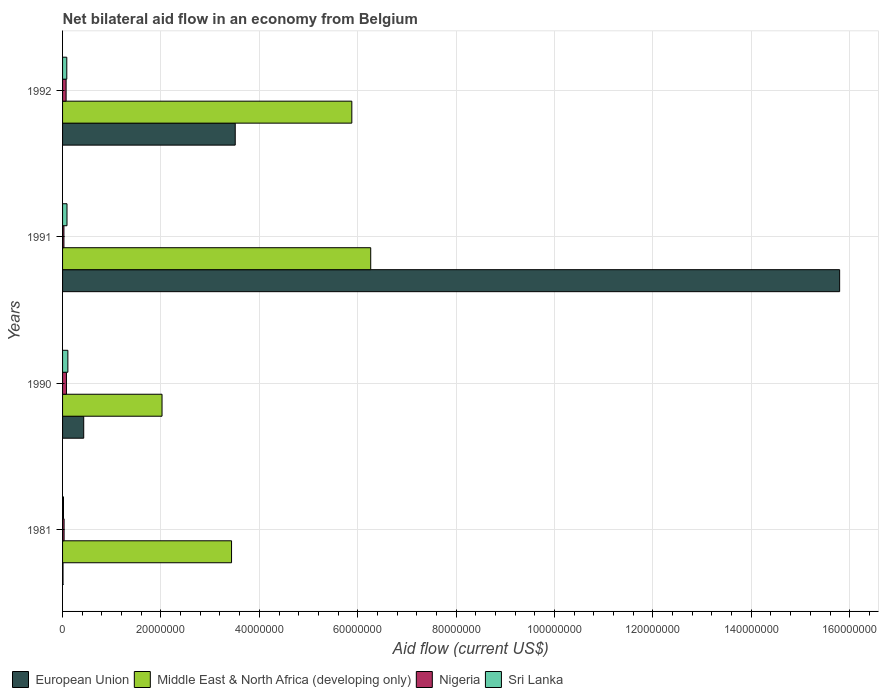How many different coloured bars are there?
Offer a terse response. 4. How many groups of bars are there?
Your response must be concise. 4. Are the number of bars per tick equal to the number of legend labels?
Your response must be concise. Yes. Are the number of bars on each tick of the Y-axis equal?
Offer a very short reply. Yes. What is the label of the 2nd group of bars from the top?
Offer a very short reply. 1991. In how many cases, is the number of bars for a given year not equal to the number of legend labels?
Give a very brief answer. 0. What is the net bilateral aid flow in Middle East & North Africa (developing only) in 1990?
Offer a terse response. 2.02e+07. Across all years, what is the maximum net bilateral aid flow in Sri Lanka?
Provide a short and direct response. 1.08e+06. In which year was the net bilateral aid flow in Middle East & North Africa (developing only) maximum?
Offer a terse response. 1991. What is the total net bilateral aid flow in Middle East & North Africa (developing only) in the graph?
Your answer should be compact. 1.76e+08. What is the difference between the net bilateral aid flow in European Union in 1991 and that in 1992?
Your answer should be compact. 1.23e+08. What is the difference between the net bilateral aid flow in European Union in 1981 and the net bilateral aid flow in Sri Lanka in 1990?
Make the answer very short. -9.90e+05. What is the average net bilateral aid flow in Middle East & North Africa (developing only) per year?
Offer a very short reply. 4.40e+07. In how many years, is the net bilateral aid flow in Sri Lanka greater than 84000000 US$?
Ensure brevity in your answer.  0. What is the ratio of the net bilateral aid flow in European Union in 1981 to that in 1992?
Your response must be concise. 0. Is the net bilateral aid flow in Middle East & North Africa (developing only) in 1981 less than that in 1991?
Your answer should be compact. Yes. What is the difference between the highest and the second highest net bilateral aid flow in Middle East & North Africa (developing only)?
Your answer should be very brief. 3.84e+06. What is the difference between the highest and the lowest net bilateral aid flow in Middle East & North Africa (developing only)?
Your response must be concise. 4.24e+07. Is it the case that in every year, the sum of the net bilateral aid flow in Middle East & North Africa (developing only) and net bilateral aid flow in European Union is greater than the sum of net bilateral aid flow in Sri Lanka and net bilateral aid flow in Nigeria?
Provide a short and direct response. Yes. What does the 2nd bar from the top in 1981 represents?
Your response must be concise. Nigeria. What does the 4th bar from the bottom in 1981 represents?
Offer a terse response. Sri Lanka. Is it the case that in every year, the sum of the net bilateral aid flow in Nigeria and net bilateral aid flow in Middle East & North Africa (developing only) is greater than the net bilateral aid flow in European Union?
Give a very brief answer. No. How many years are there in the graph?
Offer a very short reply. 4. What is the difference between two consecutive major ticks on the X-axis?
Make the answer very short. 2.00e+07. How many legend labels are there?
Offer a terse response. 4. How are the legend labels stacked?
Your answer should be very brief. Horizontal. What is the title of the graph?
Your answer should be very brief. Net bilateral aid flow in an economy from Belgium. Does "Slovenia" appear as one of the legend labels in the graph?
Offer a terse response. No. What is the label or title of the Y-axis?
Make the answer very short. Years. What is the Aid flow (current US$) of European Union in 1981?
Provide a short and direct response. 9.00e+04. What is the Aid flow (current US$) of Middle East & North Africa (developing only) in 1981?
Your response must be concise. 3.44e+07. What is the Aid flow (current US$) of Nigeria in 1981?
Make the answer very short. 3.10e+05. What is the Aid flow (current US$) in Sri Lanka in 1981?
Provide a succinct answer. 1.90e+05. What is the Aid flow (current US$) of European Union in 1990?
Give a very brief answer. 4.30e+06. What is the Aid flow (current US$) of Middle East & North Africa (developing only) in 1990?
Your response must be concise. 2.02e+07. What is the Aid flow (current US$) of Nigeria in 1990?
Give a very brief answer. 7.90e+05. What is the Aid flow (current US$) in Sri Lanka in 1990?
Offer a very short reply. 1.08e+06. What is the Aid flow (current US$) in European Union in 1991?
Offer a terse response. 1.58e+08. What is the Aid flow (current US$) of Middle East & North Africa (developing only) in 1991?
Keep it short and to the point. 6.26e+07. What is the Aid flow (current US$) in European Union in 1992?
Your answer should be very brief. 3.51e+07. What is the Aid flow (current US$) of Middle East & North Africa (developing only) in 1992?
Provide a succinct answer. 5.88e+07. What is the Aid flow (current US$) in Nigeria in 1992?
Your answer should be compact. 7.20e+05. What is the Aid flow (current US$) of Sri Lanka in 1992?
Make the answer very short. 8.60e+05. Across all years, what is the maximum Aid flow (current US$) of European Union?
Offer a terse response. 1.58e+08. Across all years, what is the maximum Aid flow (current US$) in Middle East & North Africa (developing only)?
Your answer should be compact. 6.26e+07. Across all years, what is the maximum Aid flow (current US$) in Nigeria?
Give a very brief answer. 7.90e+05. Across all years, what is the maximum Aid flow (current US$) of Sri Lanka?
Provide a short and direct response. 1.08e+06. Across all years, what is the minimum Aid flow (current US$) in Middle East & North Africa (developing only)?
Give a very brief answer. 2.02e+07. Across all years, what is the minimum Aid flow (current US$) of Nigeria?
Provide a succinct answer. 2.80e+05. Across all years, what is the minimum Aid flow (current US$) in Sri Lanka?
Offer a terse response. 1.90e+05. What is the total Aid flow (current US$) in European Union in the graph?
Your response must be concise. 1.97e+08. What is the total Aid flow (current US$) of Middle East & North Africa (developing only) in the graph?
Offer a very short reply. 1.76e+08. What is the total Aid flow (current US$) of Nigeria in the graph?
Offer a terse response. 2.10e+06. What is the total Aid flow (current US$) in Sri Lanka in the graph?
Offer a terse response. 3.03e+06. What is the difference between the Aid flow (current US$) of European Union in 1981 and that in 1990?
Offer a very short reply. -4.21e+06. What is the difference between the Aid flow (current US$) of Middle East & North Africa (developing only) in 1981 and that in 1990?
Provide a succinct answer. 1.41e+07. What is the difference between the Aid flow (current US$) in Nigeria in 1981 and that in 1990?
Provide a succinct answer. -4.80e+05. What is the difference between the Aid flow (current US$) in Sri Lanka in 1981 and that in 1990?
Provide a short and direct response. -8.90e+05. What is the difference between the Aid flow (current US$) in European Union in 1981 and that in 1991?
Your response must be concise. -1.58e+08. What is the difference between the Aid flow (current US$) in Middle East & North Africa (developing only) in 1981 and that in 1991?
Give a very brief answer. -2.83e+07. What is the difference between the Aid flow (current US$) of Nigeria in 1981 and that in 1991?
Offer a terse response. 3.00e+04. What is the difference between the Aid flow (current US$) in Sri Lanka in 1981 and that in 1991?
Keep it short and to the point. -7.10e+05. What is the difference between the Aid flow (current US$) in European Union in 1981 and that in 1992?
Make the answer very short. -3.50e+07. What is the difference between the Aid flow (current US$) in Middle East & North Africa (developing only) in 1981 and that in 1992?
Your answer should be compact. -2.44e+07. What is the difference between the Aid flow (current US$) in Nigeria in 1981 and that in 1992?
Offer a very short reply. -4.10e+05. What is the difference between the Aid flow (current US$) of Sri Lanka in 1981 and that in 1992?
Keep it short and to the point. -6.70e+05. What is the difference between the Aid flow (current US$) of European Union in 1990 and that in 1991?
Offer a terse response. -1.54e+08. What is the difference between the Aid flow (current US$) in Middle East & North Africa (developing only) in 1990 and that in 1991?
Make the answer very short. -4.24e+07. What is the difference between the Aid flow (current US$) of Nigeria in 1990 and that in 1991?
Give a very brief answer. 5.10e+05. What is the difference between the Aid flow (current US$) in Sri Lanka in 1990 and that in 1991?
Your answer should be compact. 1.80e+05. What is the difference between the Aid flow (current US$) in European Union in 1990 and that in 1992?
Your answer should be compact. -3.08e+07. What is the difference between the Aid flow (current US$) of Middle East & North Africa (developing only) in 1990 and that in 1992?
Your answer should be compact. -3.86e+07. What is the difference between the Aid flow (current US$) in Nigeria in 1990 and that in 1992?
Provide a succinct answer. 7.00e+04. What is the difference between the Aid flow (current US$) in Sri Lanka in 1990 and that in 1992?
Give a very brief answer. 2.20e+05. What is the difference between the Aid flow (current US$) of European Union in 1991 and that in 1992?
Give a very brief answer. 1.23e+08. What is the difference between the Aid flow (current US$) of Middle East & North Africa (developing only) in 1991 and that in 1992?
Keep it short and to the point. 3.84e+06. What is the difference between the Aid flow (current US$) in Nigeria in 1991 and that in 1992?
Make the answer very short. -4.40e+05. What is the difference between the Aid flow (current US$) of European Union in 1981 and the Aid flow (current US$) of Middle East & North Africa (developing only) in 1990?
Ensure brevity in your answer.  -2.01e+07. What is the difference between the Aid flow (current US$) in European Union in 1981 and the Aid flow (current US$) in Nigeria in 1990?
Keep it short and to the point. -7.00e+05. What is the difference between the Aid flow (current US$) in European Union in 1981 and the Aid flow (current US$) in Sri Lanka in 1990?
Make the answer very short. -9.90e+05. What is the difference between the Aid flow (current US$) in Middle East & North Africa (developing only) in 1981 and the Aid flow (current US$) in Nigeria in 1990?
Your answer should be compact. 3.36e+07. What is the difference between the Aid flow (current US$) of Middle East & North Africa (developing only) in 1981 and the Aid flow (current US$) of Sri Lanka in 1990?
Ensure brevity in your answer.  3.33e+07. What is the difference between the Aid flow (current US$) of Nigeria in 1981 and the Aid flow (current US$) of Sri Lanka in 1990?
Your answer should be very brief. -7.70e+05. What is the difference between the Aid flow (current US$) of European Union in 1981 and the Aid flow (current US$) of Middle East & North Africa (developing only) in 1991?
Keep it short and to the point. -6.26e+07. What is the difference between the Aid flow (current US$) in European Union in 1981 and the Aid flow (current US$) in Sri Lanka in 1991?
Offer a terse response. -8.10e+05. What is the difference between the Aid flow (current US$) in Middle East & North Africa (developing only) in 1981 and the Aid flow (current US$) in Nigeria in 1991?
Give a very brief answer. 3.41e+07. What is the difference between the Aid flow (current US$) of Middle East & North Africa (developing only) in 1981 and the Aid flow (current US$) of Sri Lanka in 1991?
Make the answer very short. 3.34e+07. What is the difference between the Aid flow (current US$) of Nigeria in 1981 and the Aid flow (current US$) of Sri Lanka in 1991?
Your answer should be compact. -5.90e+05. What is the difference between the Aid flow (current US$) in European Union in 1981 and the Aid flow (current US$) in Middle East & North Africa (developing only) in 1992?
Keep it short and to the point. -5.87e+07. What is the difference between the Aid flow (current US$) of European Union in 1981 and the Aid flow (current US$) of Nigeria in 1992?
Your answer should be very brief. -6.30e+05. What is the difference between the Aid flow (current US$) in European Union in 1981 and the Aid flow (current US$) in Sri Lanka in 1992?
Your answer should be compact. -7.70e+05. What is the difference between the Aid flow (current US$) of Middle East & North Africa (developing only) in 1981 and the Aid flow (current US$) of Nigeria in 1992?
Offer a terse response. 3.36e+07. What is the difference between the Aid flow (current US$) in Middle East & North Africa (developing only) in 1981 and the Aid flow (current US$) in Sri Lanka in 1992?
Your response must be concise. 3.35e+07. What is the difference between the Aid flow (current US$) of Nigeria in 1981 and the Aid flow (current US$) of Sri Lanka in 1992?
Offer a terse response. -5.50e+05. What is the difference between the Aid flow (current US$) of European Union in 1990 and the Aid flow (current US$) of Middle East & North Africa (developing only) in 1991?
Give a very brief answer. -5.83e+07. What is the difference between the Aid flow (current US$) of European Union in 1990 and the Aid flow (current US$) of Nigeria in 1991?
Offer a terse response. 4.02e+06. What is the difference between the Aid flow (current US$) of European Union in 1990 and the Aid flow (current US$) of Sri Lanka in 1991?
Make the answer very short. 3.40e+06. What is the difference between the Aid flow (current US$) in Middle East & North Africa (developing only) in 1990 and the Aid flow (current US$) in Nigeria in 1991?
Offer a very short reply. 1.99e+07. What is the difference between the Aid flow (current US$) of Middle East & North Africa (developing only) in 1990 and the Aid flow (current US$) of Sri Lanka in 1991?
Provide a short and direct response. 1.93e+07. What is the difference between the Aid flow (current US$) in European Union in 1990 and the Aid flow (current US$) in Middle East & North Africa (developing only) in 1992?
Your answer should be very brief. -5.45e+07. What is the difference between the Aid flow (current US$) of European Union in 1990 and the Aid flow (current US$) of Nigeria in 1992?
Provide a short and direct response. 3.58e+06. What is the difference between the Aid flow (current US$) in European Union in 1990 and the Aid flow (current US$) in Sri Lanka in 1992?
Offer a very short reply. 3.44e+06. What is the difference between the Aid flow (current US$) of Middle East & North Africa (developing only) in 1990 and the Aid flow (current US$) of Nigeria in 1992?
Ensure brevity in your answer.  1.95e+07. What is the difference between the Aid flow (current US$) of Middle East & North Africa (developing only) in 1990 and the Aid flow (current US$) of Sri Lanka in 1992?
Offer a terse response. 1.94e+07. What is the difference between the Aid flow (current US$) in Nigeria in 1990 and the Aid flow (current US$) in Sri Lanka in 1992?
Your answer should be compact. -7.00e+04. What is the difference between the Aid flow (current US$) in European Union in 1991 and the Aid flow (current US$) in Middle East & North Africa (developing only) in 1992?
Provide a succinct answer. 9.92e+07. What is the difference between the Aid flow (current US$) in European Union in 1991 and the Aid flow (current US$) in Nigeria in 1992?
Your response must be concise. 1.57e+08. What is the difference between the Aid flow (current US$) of European Union in 1991 and the Aid flow (current US$) of Sri Lanka in 1992?
Provide a short and direct response. 1.57e+08. What is the difference between the Aid flow (current US$) in Middle East & North Africa (developing only) in 1991 and the Aid flow (current US$) in Nigeria in 1992?
Provide a short and direct response. 6.19e+07. What is the difference between the Aid flow (current US$) of Middle East & North Africa (developing only) in 1991 and the Aid flow (current US$) of Sri Lanka in 1992?
Offer a terse response. 6.18e+07. What is the difference between the Aid flow (current US$) in Nigeria in 1991 and the Aid flow (current US$) in Sri Lanka in 1992?
Keep it short and to the point. -5.80e+05. What is the average Aid flow (current US$) of European Union per year?
Your response must be concise. 4.94e+07. What is the average Aid flow (current US$) of Middle East & North Africa (developing only) per year?
Offer a very short reply. 4.40e+07. What is the average Aid flow (current US$) of Nigeria per year?
Your answer should be compact. 5.25e+05. What is the average Aid flow (current US$) in Sri Lanka per year?
Your response must be concise. 7.58e+05. In the year 1981, what is the difference between the Aid flow (current US$) in European Union and Aid flow (current US$) in Middle East & North Africa (developing only)?
Provide a succinct answer. -3.43e+07. In the year 1981, what is the difference between the Aid flow (current US$) in European Union and Aid flow (current US$) in Sri Lanka?
Offer a terse response. -1.00e+05. In the year 1981, what is the difference between the Aid flow (current US$) in Middle East & North Africa (developing only) and Aid flow (current US$) in Nigeria?
Offer a very short reply. 3.40e+07. In the year 1981, what is the difference between the Aid flow (current US$) of Middle East & North Africa (developing only) and Aid flow (current US$) of Sri Lanka?
Keep it short and to the point. 3.42e+07. In the year 1990, what is the difference between the Aid flow (current US$) in European Union and Aid flow (current US$) in Middle East & North Africa (developing only)?
Keep it short and to the point. -1.59e+07. In the year 1990, what is the difference between the Aid flow (current US$) in European Union and Aid flow (current US$) in Nigeria?
Your answer should be compact. 3.51e+06. In the year 1990, what is the difference between the Aid flow (current US$) of European Union and Aid flow (current US$) of Sri Lanka?
Give a very brief answer. 3.22e+06. In the year 1990, what is the difference between the Aid flow (current US$) in Middle East & North Africa (developing only) and Aid flow (current US$) in Nigeria?
Your response must be concise. 1.94e+07. In the year 1990, what is the difference between the Aid flow (current US$) in Middle East & North Africa (developing only) and Aid flow (current US$) in Sri Lanka?
Your answer should be very brief. 1.91e+07. In the year 1990, what is the difference between the Aid flow (current US$) of Nigeria and Aid flow (current US$) of Sri Lanka?
Your answer should be very brief. -2.90e+05. In the year 1991, what is the difference between the Aid flow (current US$) in European Union and Aid flow (current US$) in Middle East & North Africa (developing only)?
Provide a succinct answer. 9.53e+07. In the year 1991, what is the difference between the Aid flow (current US$) in European Union and Aid flow (current US$) in Nigeria?
Offer a terse response. 1.58e+08. In the year 1991, what is the difference between the Aid flow (current US$) of European Union and Aid flow (current US$) of Sri Lanka?
Your answer should be compact. 1.57e+08. In the year 1991, what is the difference between the Aid flow (current US$) in Middle East & North Africa (developing only) and Aid flow (current US$) in Nigeria?
Your response must be concise. 6.24e+07. In the year 1991, what is the difference between the Aid flow (current US$) in Middle East & North Africa (developing only) and Aid flow (current US$) in Sri Lanka?
Offer a terse response. 6.17e+07. In the year 1991, what is the difference between the Aid flow (current US$) of Nigeria and Aid flow (current US$) of Sri Lanka?
Your answer should be very brief. -6.20e+05. In the year 1992, what is the difference between the Aid flow (current US$) in European Union and Aid flow (current US$) in Middle East & North Africa (developing only)?
Keep it short and to the point. -2.37e+07. In the year 1992, what is the difference between the Aid flow (current US$) in European Union and Aid flow (current US$) in Nigeria?
Keep it short and to the point. 3.44e+07. In the year 1992, what is the difference between the Aid flow (current US$) of European Union and Aid flow (current US$) of Sri Lanka?
Your answer should be compact. 3.42e+07. In the year 1992, what is the difference between the Aid flow (current US$) of Middle East & North Africa (developing only) and Aid flow (current US$) of Nigeria?
Give a very brief answer. 5.81e+07. In the year 1992, what is the difference between the Aid flow (current US$) of Middle East & North Africa (developing only) and Aid flow (current US$) of Sri Lanka?
Your answer should be compact. 5.79e+07. What is the ratio of the Aid flow (current US$) of European Union in 1981 to that in 1990?
Offer a very short reply. 0.02. What is the ratio of the Aid flow (current US$) in Middle East & North Africa (developing only) in 1981 to that in 1990?
Offer a terse response. 1.7. What is the ratio of the Aid flow (current US$) of Nigeria in 1981 to that in 1990?
Your answer should be very brief. 0.39. What is the ratio of the Aid flow (current US$) in Sri Lanka in 1981 to that in 1990?
Keep it short and to the point. 0.18. What is the ratio of the Aid flow (current US$) of European Union in 1981 to that in 1991?
Make the answer very short. 0. What is the ratio of the Aid flow (current US$) of Middle East & North Africa (developing only) in 1981 to that in 1991?
Offer a very short reply. 0.55. What is the ratio of the Aid flow (current US$) in Nigeria in 1981 to that in 1991?
Ensure brevity in your answer.  1.11. What is the ratio of the Aid flow (current US$) of Sri Lanka in 1981 to that in 1991?
Your response must be concise. 0.21. What is the ratio of the Aid flow (current US$) of European Union in 1981 to that in 1992?
Make the answer very short. 0. What is the ratio of the Aid flow (current US$) of Middle East & North Africa (developing only) in 1981 to that in 1992?
Ensure brevity in your answer.  0.58. What is the ratio of the Aid flow (current US$) of Nigeria in 1981 to that in 1992?
Make the answer very short. 0.43. What is the ratio of the Aid flow (current US$) in Sri Lanka in 1981 to that in 1992?
Ensure brevity in your answer.  0.22. What is the ratio of the Aid flow (current US$) in European Union in 1990 to that in 1991?
Provide a short and direct response. 0.03. What is the ratio of the Aid flow (current US$) in Middle East & North Africa (developing only) in 1990 to that in 1991?
Give a very brief answer. 0.32. What is the ratio of the Aid flow (current US$) in Nigeria in 1990 to that in 1991?
Your answer should be compact. 2.82. What is the ratio of the Aid flow (current US$) in Sri Lanka in 1990 to that in 1991?
Your response must be concise. 1.2. What is the ratio of the Aid flow (current US$) of European Union in 1990 to that in 1992?
Give a very brief answer. 0.12. What is the ratio of the Aid flow (current US$) of Middle East & North Africa (developing only) in 1990 to that in 1992?
Provide a short and direct response. 0.34. What is the ratio of the Aid flow (current US$) in Nigeria in 1990 to that in 1992?
Your answer should be very brief. 1.1. What is the ratio of the Aid flow (current US$) of Sri Lanka in 1990 to that in 1992?
Keep it short and to the point. 1.26. What is the ratio of the Aid flow (current US$) of European Union in 1991 to that in 1992?
Give a very brief answer. 4.5. What is the ratio of the Aid flow (current US$) in Middle East & North Africa (developing only) in 1991 to that in 1992?
Give a very brief answer. 1.07. What is the ratio of the Aid flow (current US$) of Nigeria in 1991 to that in 1992?
Provide a short and direct response. 0.39. What is the ratio of the Aid flow (current US$) of Sri Lanka in 1991 to that in 1992?
Give a very brief answer. 1.05. What is the difference between the highest and the second highest Aid flow (current US$) in European Union?
Offer a terse response. 1.23e+08. What is the difference between the highest and the second highest Aid flow (current US$) of Middle East & North Africa (developing only)?
Keep it short and to the point. 3.84e+06. What is the difference between the highest and the second highest Aid flow (current US$) of Nigeria?
Your response must be concise. 7.00e+04. What is the difference between the highest and the second highest Aid flow (current US$) of Sri Lanka?
Provide a succinct answer. 1.80e+05. What is the difference between the highest and the lowest Aid flow (current US$) in European Union?
Your answer should be compact. 1.58e+08. What is the difference between the highest and the lowest Aid flow (current US$) of Middle East & North Africa (developing only)?
Your answer should be very brief. 4.24e+07. What is the difference between the highest and the lowest Aid flow (current US$) of Nigeria?
Keep it short and to the point. 5.10e+05. What is the difference between the highest and the lowest Aid flow (current US$) in Sri Lanka?
Provide a succinct answer. 8.90e+05. 